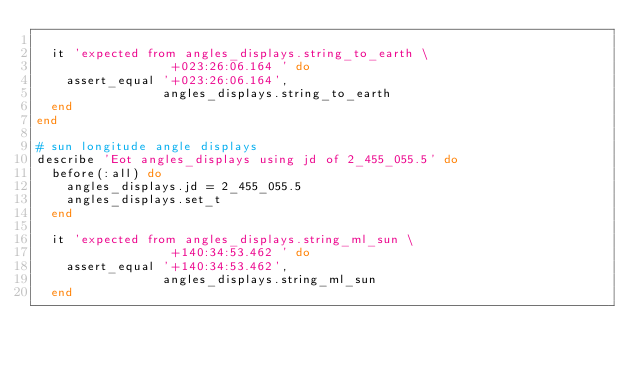<code> <loc_0><loc_0><loc_500><loc_500><_Ruby_>
  it 'expected from angles_displays.string_to_earth \
                  +023:26:06.164 ' do
    assert_equal '+023:26:06.164',
                 angles_displays.string_to_earth
  end
end

# sun longitude angle displays
describe 'Eot angles_displays using jd of 2_455_055.5' do
  before(:all) do
    angles_displays.jd = 2_455_055.5
    angles_displays.set_t
  end

  it 'expected from angles_displays.string_ml_sun \
                  +140:34:53.462 ' do
    assert_equal '+140:34:53.462',
                 angles_displays.string_ml_sun
  end
</code> 